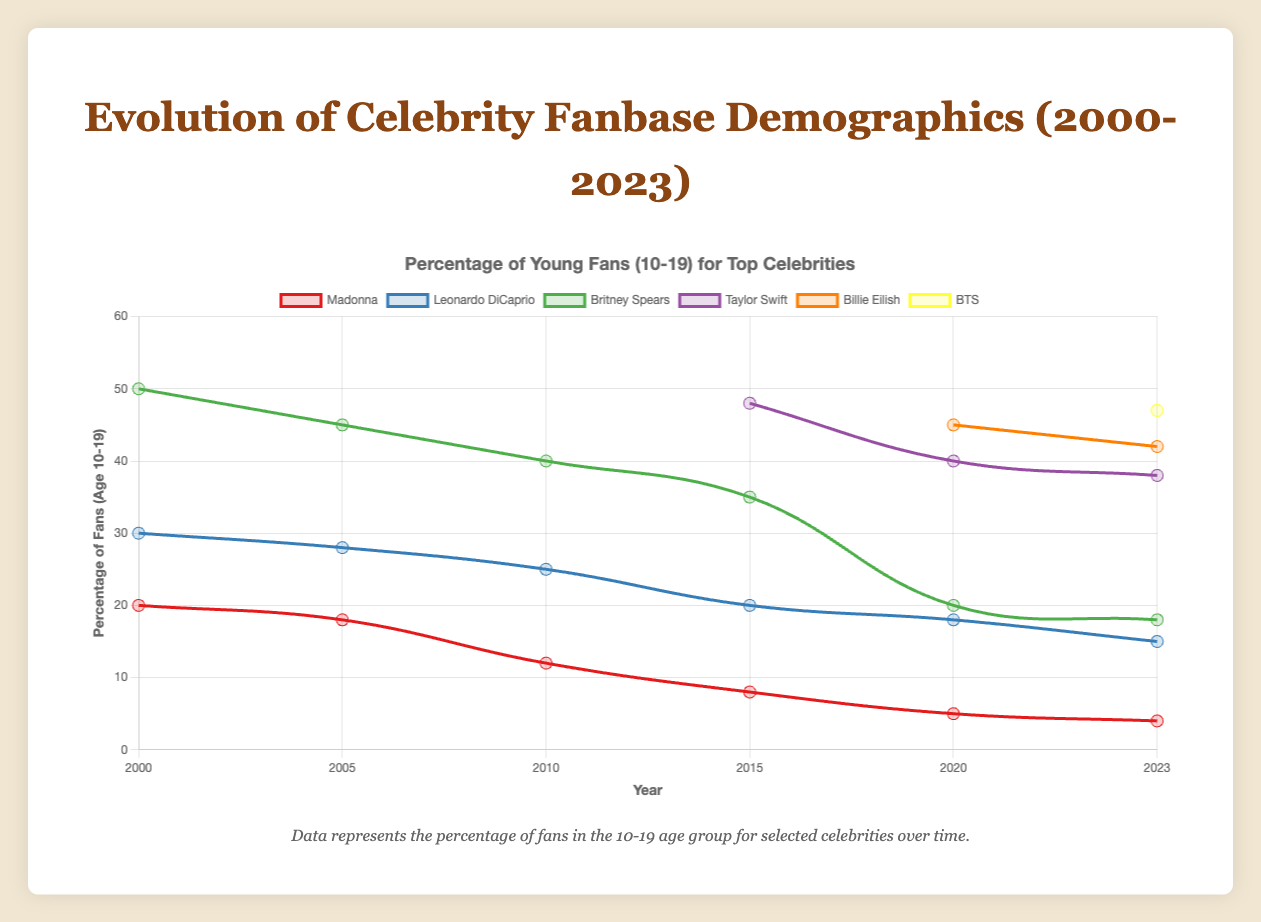Which celebrity had the highest percentage of fans in the 10-19 age group in the year 2000? In the year 2000, the chart shows that Britney Spears had the highest percentage of fans in the 10-19 age group, with 50%.
Answer: Britney Spears How did the percentage of fans aged 10-19 for Madonna change from 2000 to 2023? Madonna's percentage in the 10-19 age group decreased over the years from 20% in 2000 to 4% in 2023, showing a continuous decline.
Answer: Decreased Which two celebrities had the most similar percentage of fans aged 10-19 in 2023? In 2023, Billie Eilish and BTS had very similar percentages of fans aged 10-19, with 42% for Billie Eilish and 47% for BTS, making them the most similar.
Answer: Billie Eilish and BTS Compare the changes in percentage of 10-19 age group fans for Leonardo DiCaprio and Britney Spears from 2005 to 2020. From 2005 to 2020, Leonardo DiCaprio's percentage of 10-19 age group fans decreased from 28% to 18%, whereas Britney Spears' percentage decreased from 45% to 20%. Both experienced declines but at different rates.
Answer: Both decreased; Leonardo DiCaprio from 28% to 18%, Britney Spears from 45% to 20% Which celebrity introduced in or after 2015 had the highest percentage of fans aged 10-19 in 2023? In 2023, BTS, introduced after 2015, had the highest percentage of fans aged 10-19 at 47%.
Answer: BTS Calculate the average percentage of 10-19 age group fans for Taylor Swift from 2015 to 2023. Taylor Swift's percentages were 48% in 2015, 40% in 2020, and 38% in 2023. The average is calculated as (48 + 40 + 38) / 3 = 42%.
Answer: 42% What trend can be observed in the percentage of fans aged 10-19 for Leonardo DiCaprio from 2000 to 2023? Leonardo DiCaprio's percentage of 10-19 age group fans declined over the years from 30% in 2000 to 15% in 2023, indicating a downward trend.
Answer: Downward trend By how much did the percentage of fans aged 10-19 for Billie Eilish change from 2020 to 2023? Billie Eilish’s percentage of fans aged 10-19 slightly decreased from 45% in 2020 to 42% in 2023, a change of 3%.
Answer: Decreased by 3% Who had a greater percentage of fans aged 10-19 in 2010: Madonna or Leonardo DiCaprio? By how much? In 2010, Leonardo DiCaprio had a higher percentage of fans aged 10-19 at 25% compared to Madonna’s 12%. The difference is 13%.
Answer: Leonardo DiCaprio by 13% 